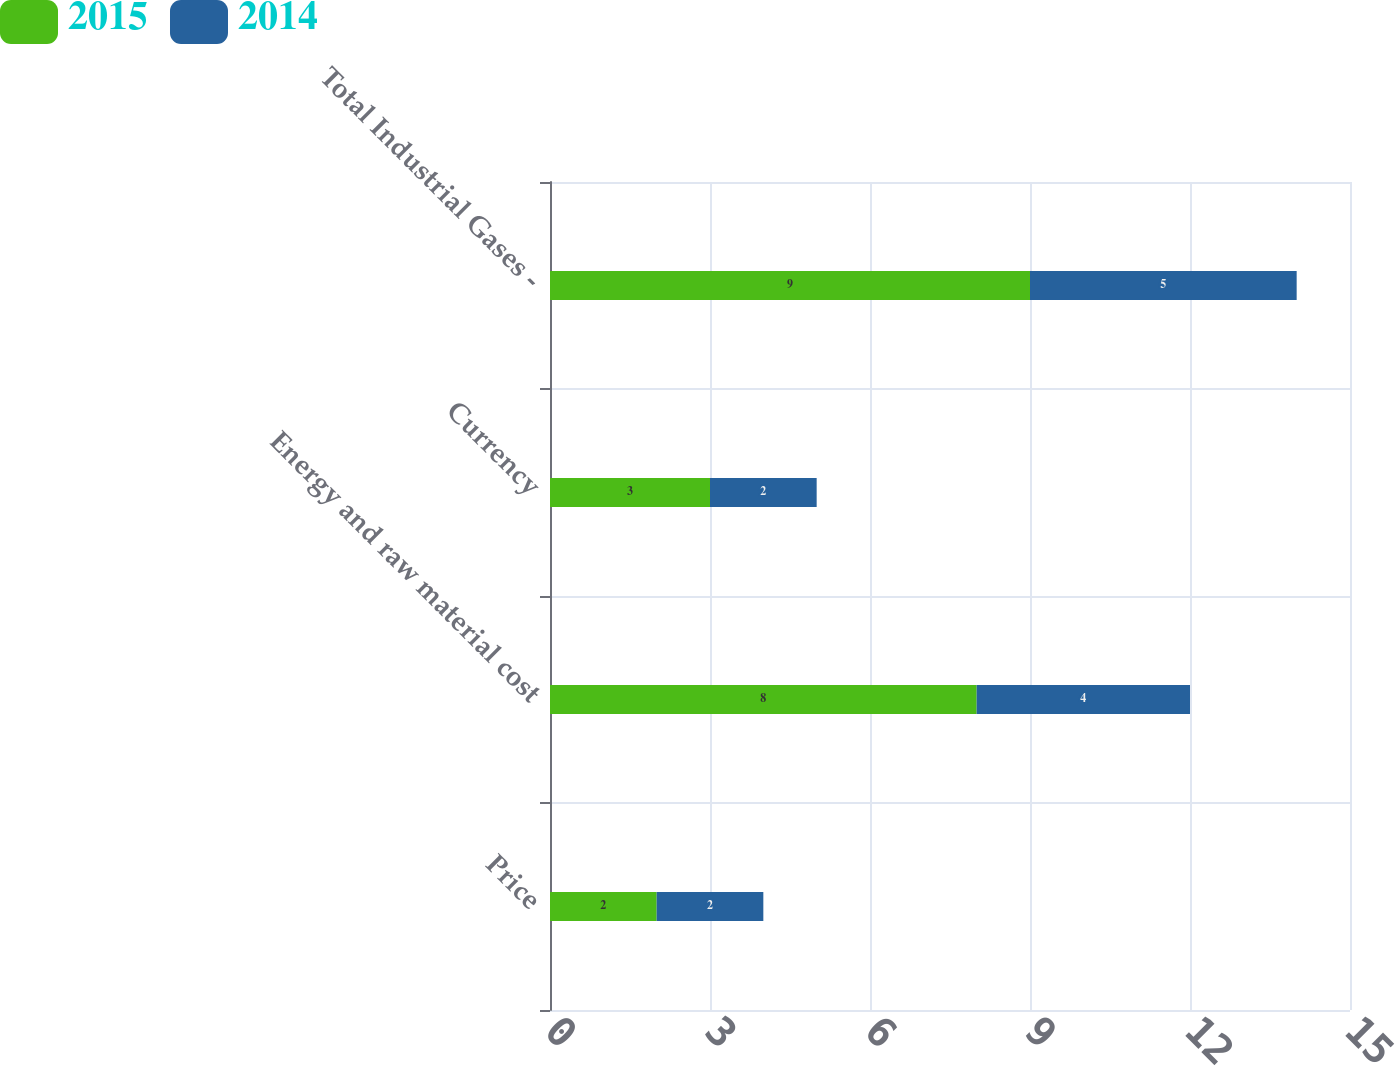Convert chart. <chart><loc_0><loc_0><loc_500><loc_500><stacked_bar_chart><ecel><fcel>Price<fcel>Energy and raw material cost<fcel>Currency<fcel>Total Industrial Gases -<nl><fcel>2015<fcel>2<fcel>8<fcel>3<fcel>9<nl><fcel>2014<fcel>2<fcel>4<fcel>2<fcel>5<nl></chart> 